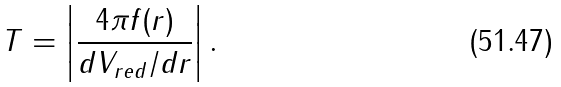<formula> <loc_0><loc_0><loc_500><loc_500>T = \left | \frac { 4 \pi f ( r ) } { d V _ { r e d } / d r } \right | .</formula> 